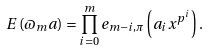Convert formula to latex. <formula><loc_0><loc_0><loc_500><loc_500>E \left ( \varpi _ { m } a \right ) = \prod _ { i = 0 } ^ { m } e _ { m - i , \pi } \left ( a _ { i } x ^ { p ^ { i } } \right ) .</formula> 